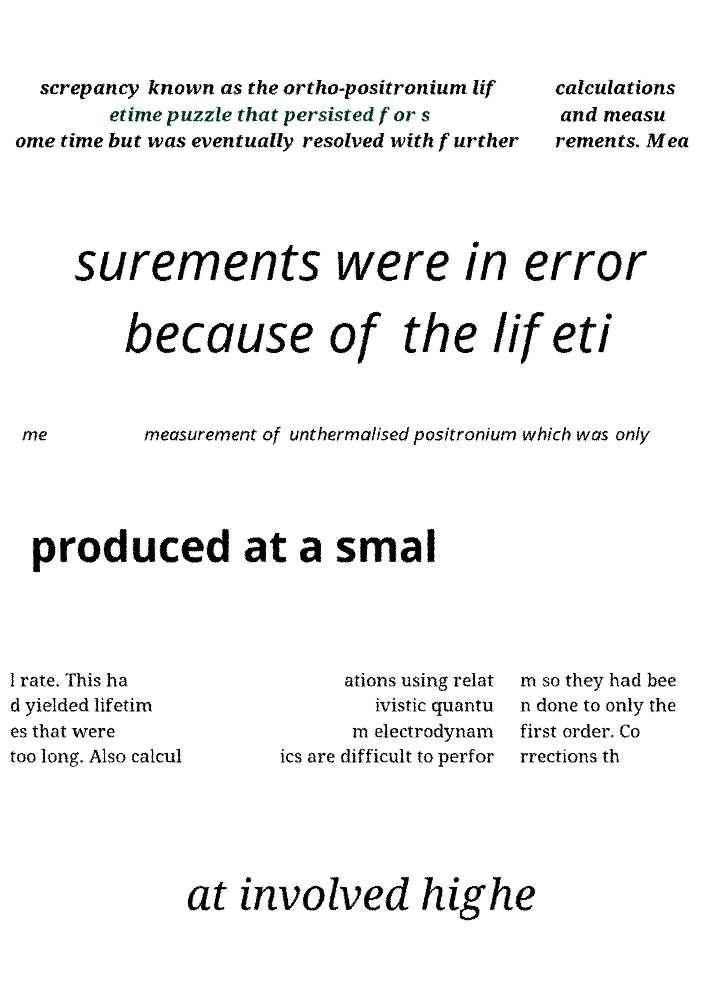I need the written content from this picture converted into text. Can you do that? screpancy known as the ortho-positronium lif etime puzzle that persisted for s ome time but was eventually resolved with further calculations and measu rements. Mea surements were in error because of the lifeti me measurement of unthermalised positronium which was only produced at a smal l rate. This ha d yielded lifetim es that were too long. Also calcul ations using relat ivistic quantu m electrodynam ics are difficult to perfor m so they had bee n done to only the first order. Co rrections th at involved highe 